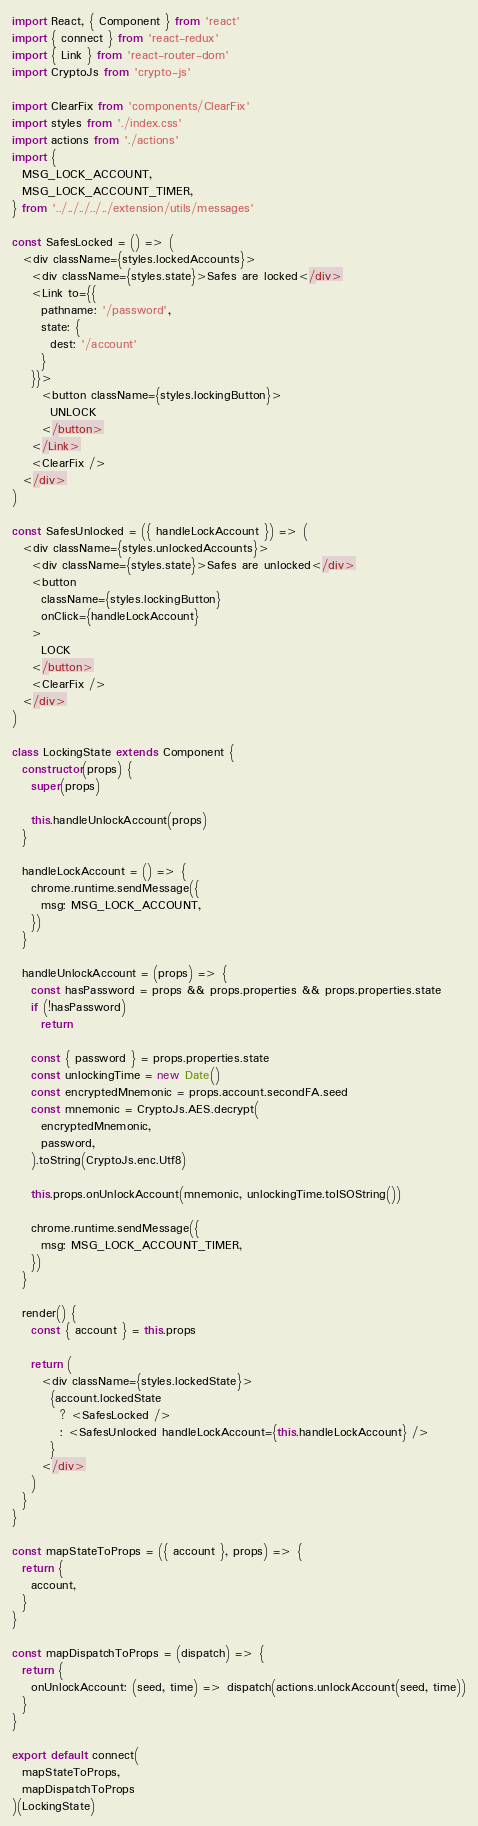<code> <loc_0><loc_0><loc_500><loc_500><_JavaScript_>import React, { Component } from 'react'
import { connect } from 'react-redux'
import { Link } from 'react-router-dom'
import CryptoJs from 'crypto-js'

import ClearFix from 'components/ClearFix'
import styles from './index.css'
import actions from './actions'
import {
  MSG_LOCK_ACCOUNT,
  MSG_LOCK_ACCOUNT_TIMER,
} from '../../../../../extension/utils/messages'

const SafesLocked = () => (
  <div className={styles.lockedAccounts}>
    <div className={styles.state}>Safes are locked</div>
    <Link to={{
      pathname: '/password',
      state: {
        dest: '/account'
      }
    }}>
      <button className={styles.lockingButton}>
        UNLOCK
      </button>
    </Link>
    <ClearFix />
  </div>
)

const SafesUnlocked = ({ handleLockAccount }) => (
  <div className={styles.unlockedAccounts}>
    <div className={styles.state}>Safes are unlocked</div>
    <button
      className={styles.lockingButton}
      onClick={handleLockAccount}
    >
      LOCK
    </button>
    <ClearFix />
  </div>
)

class LockingState extends Component {
  constructor(props) {
    super(props)

    this.handleUnlockAccount(props)
  }

  handleLockAccount = () => {
    chrome.runtime.sendMessage({
      msg: MSG_LOCK_ACCOUNT,
    })
  }

  handleUnlockAccount = (props) => {
    const hasPassword = props && props.properties && props.properties.state
    if (!hasPassword)
      return

    const { password } = props.properties.state
    const unlockingTime = new Date()
    const encryptedMnemonic = props.account.secondFA.seed
    const mnemonic = CryptoJs.AES.decrypt(
      encryptedMnemonic,
      password,
    ).toString(CryptoJs.enc.Utf8)

    this.props.onUnlockAccount(mnemonic, unlockingTime.toISOString())

    chrome.runtime.sendMessage({
      msg: MSG_LOCK_ACCOUNT_TIMER,
    })
  }

  render() {
    const { account } = this.props

    return (
      <div className={styles.lockedState}>
        {account.lockedState
          ? <SafesLocked />
          : <SafesUnlocked handleLockAccount={this.handleLockAccount} />
        }
      </div>
    )
  }
}

const mapStateToProps = ({ account }, props) => {
  return {
    account,
  }
}

const mapDispatchToProps = (dispatch) => {
  return {
    onUnlockAccount: (seed, time) => dispatch(actions.unlockAccount(seed, time))
  }
}

export default connect(
  mapStateToProps,
  mapDispatchToProps
)(LockingState)
</code> 